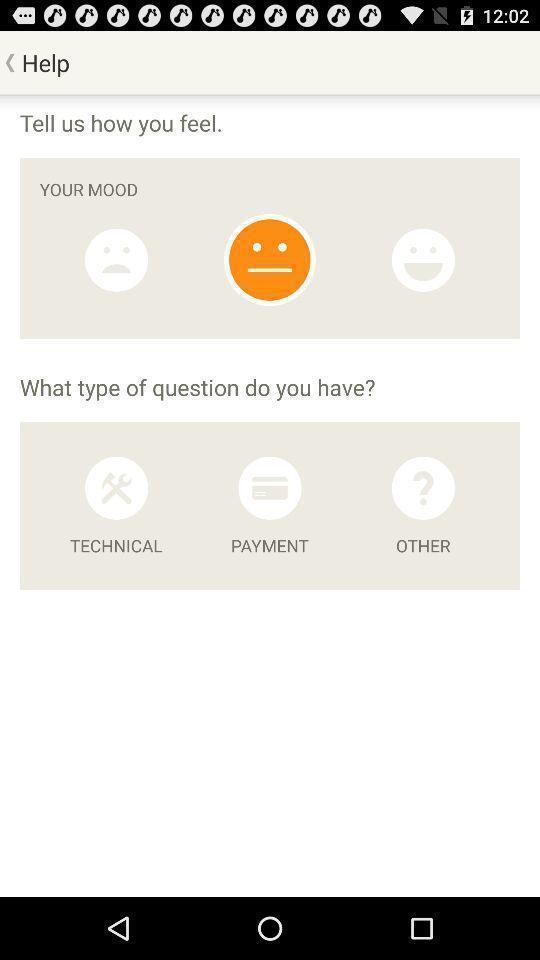Provide a textual representation of this image. Page displaying feedback questions under help. 